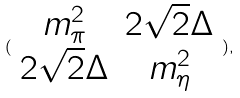Convert formula to latex. <formula><loc_0><loc_0><loc_500><loc_500>( \begin{array} { c c } m _ { \pi } ^ { 2 } & 2 \sqrt { 2 } \Delta \\ 2 \sqrt { 2 } \Delta & m _ { \eta } ^ { 2 } \end{array} ) ,</formula> 